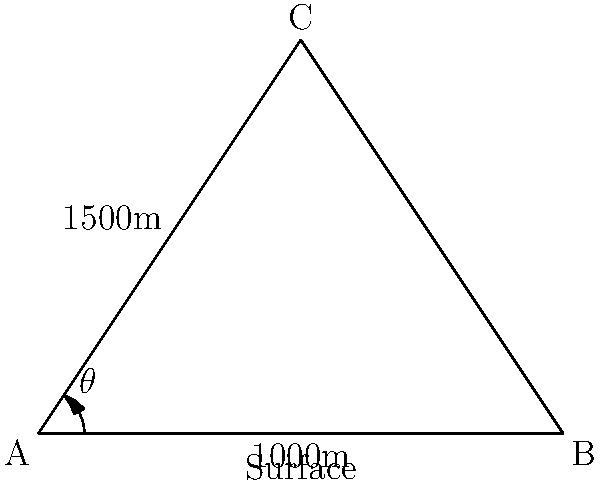In a directional drilling operation, you need to reach an oil reservoir located 1500m deep and 1000m horizontally from the drilling rig. What is the optimal angle ($\theta$) for the drill bit to follow in order to reach the target most efficiently? To find the optimal angle for directional drilling, we need to use trigonometry. Let's approach this step-by-step:

1. Identify the known variables:
   - Horizontal distance (adjacent side) = 1000m
   - Vertical depth (opposite side) = 1500m

2. Recognize that we're dealing with a right-angled triangle, where the hypotenuse represents the drilling path.

3. To find the angle, we need to use the arctangent (inverse tangent) function:
   
   $\theta = \arctan(\frac{\text{opposite}}{\text{adjacent}})$

4. Plug in the values:
   
   $\theta = \arctan(\frac{1500}{1000})$

5. Calculate:
   
   $\theta = \arctan(1.5)$
   
   $\theta \approx 56.31°$

6. Round to the nearest degree for practical application:
   
   $\theta \approx 56°$

This angle provides the most direct path to the target, minimizing the total distance drilled and thus optimizing the operation.
Answer: 56° 